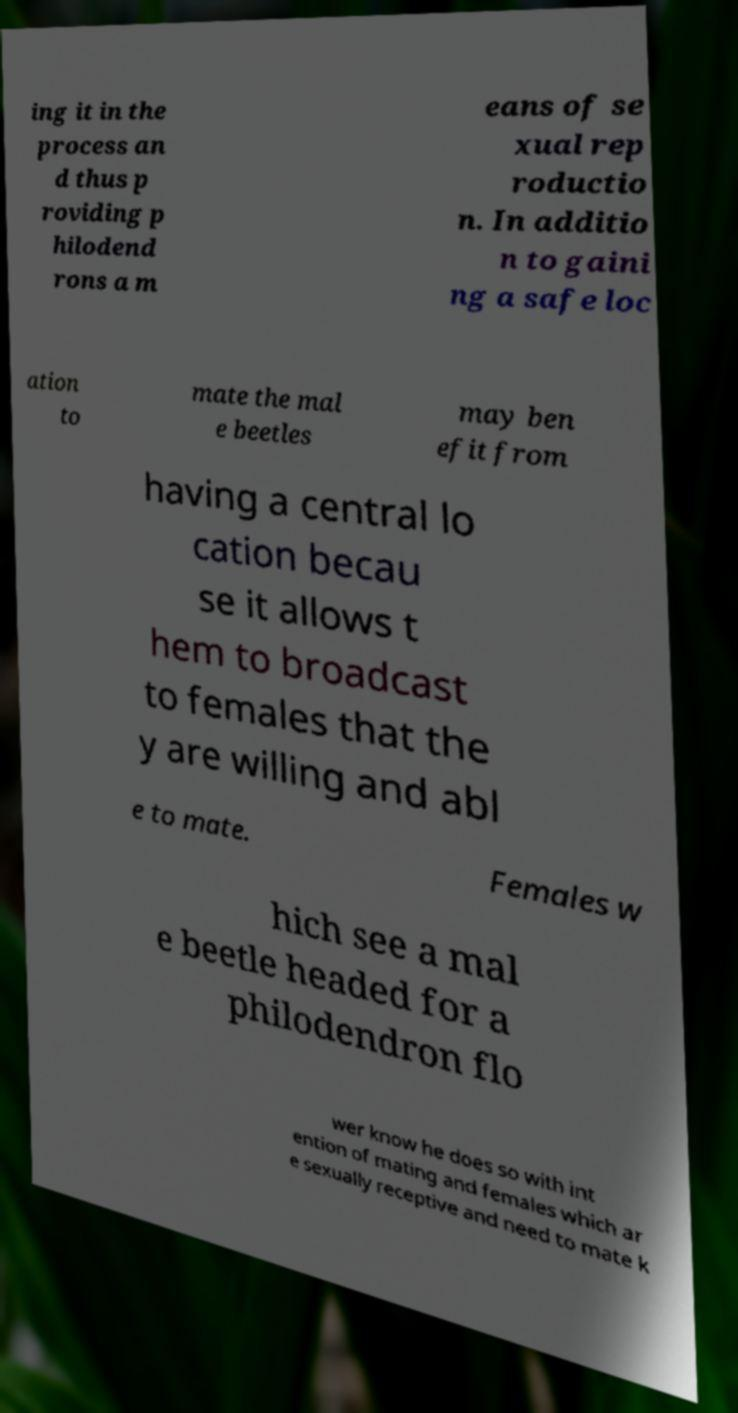I need the written content from this picture converted into text. Can you do that? ing it in the process an d thus p roviding p hilodend rons a m eans of se xual rep roductio n. In additio n to gaini ng a safe loc ation to mate the mal e beetles may ben efit from having a central lo cation becau se it allows t hem to broadcast to females that the y are willing and abl e to mate. Females w hich see a mal e beetle headed for a philodendron flo wer know he does so with int ention of mating and females which ar e sexually receptive and need to mate k 